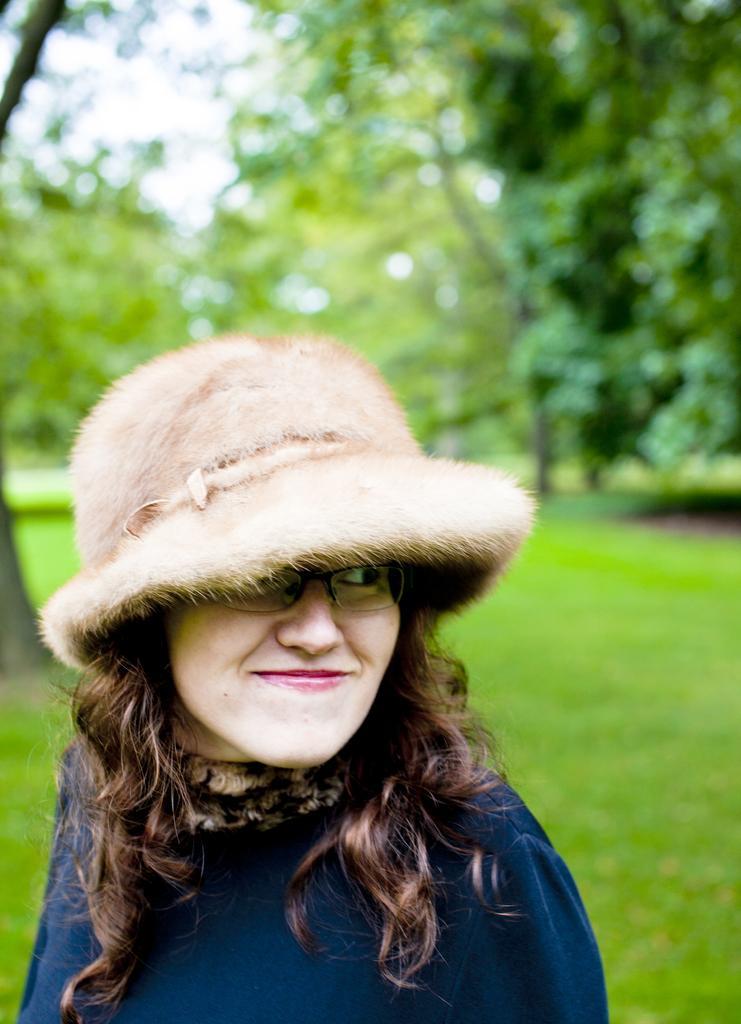How would you summarize this image in a sentence or two? In this picture, we see the woman in a blue dress who is wearing a hat is smiling. She's even wearing spectacles. At the bottom of the picture, we see grass. There are many trees in the background and it is blurred in the background. 